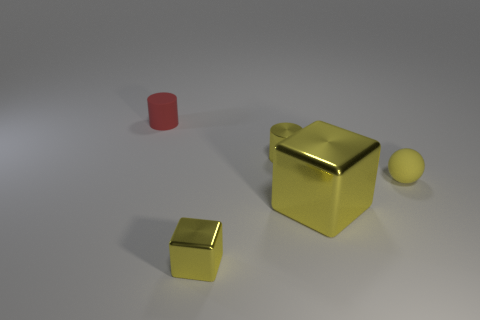Subtract 1 cylinders. How many cylinders are left? 1 Add 1 large blue balls. How many objects exist? 6 Subtract all cylinders. How many objects are left? 3 Subtract all matte cylinders. Subtract all tiny yellow cylinders. How many objects are left? 3 Add 3 rubber cylinders. How many rubber cylinders are left? 4 Add 1 rubber cylinders. How many rubber cylinders exist? 2 Subtract 1 yellow blocks. How many objects are left? 4 Subtract all red spheres. Subtract all purple blocks. How many spheres are left? 1 